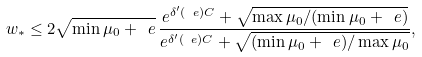Convert formula to latex. <formula><loc_0><loc_0><loc_500><loc_500>w _ { * } \leq 2 \sqrt { \min \mu _ { 0 } + \ e } \, \frac { e ^ { \delta ^ { \prime } ( \ e ) C } + \sqrt { \max \mu _ { 0 } / ( \min \mu _ { 0 } + \ e ) } } { e ^ { \delta ^ { \prime } ( \ e ) C } + \sqrt { ( \min \mu _ { 0 } + \ e ) / \max \mu _ { 0 } } } ,</formula> 